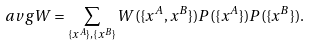Convert formula to latex. <formula><loc_0><loc_0><loc_500><loc_500>\ a v g { W } = \sum _ { \{ x ^ { A } \} , \{ x ^ { B } \} } W ( \{ x ^ { A } , x ^ { B } \} ) P ( \{ x ^ { A } \} ) P ( \{ x ^ { B } \} ) .</formula> 